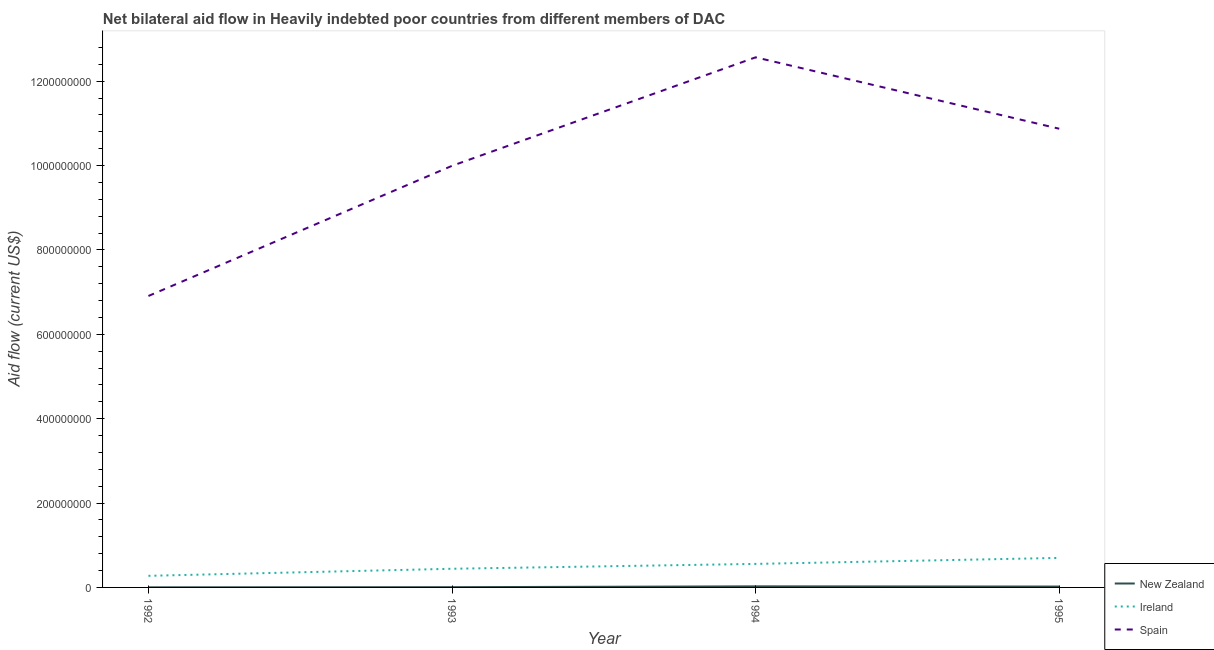Is the number of lines equal to the number of legend labels?
Ensure brevity in your answer.  Yes. What is the amount of aid provided by new zealand in 1992?
Ensure brevity in your answer.  2.30e+05. Across all years, what is the maximum amount of aid provided by spain?
Provide a succinct answer. 1.26e+09. Across all years, what is the minimum amount of aid provided by ireland?
Offer a very short reply. 2.75e+07. In which year was the amount of aid provided by ireland maximum?
Your response must be concise. 1995. In which year was the amount of aid provided by spain minimum?
Offer a very short reply. 1992. What is the total amount of aid provided by ireland in the graph?
Keep it short and to the point. 1.97e+08. What is the difference between the amount of aid provided by ireland in 1992 and that in 1995?
Make the answer very short. -4.25e+07. What is the difference between the amount of aid provided by new zealand in 1995 and the amount of aid provided by ireland in 1993?
Provide a succinct answer. -4.22e+07. What is the average amount of aid provided by spain per year?
Your response must be concise. 1.01e+09. In the year 1995, what is the difference between the amount of aid provided by new zealand and amount of aid provided by ireland?
Make the answer very short. -6.79e+07. What is the ratio of the amount of aid provided by ireland in 1992 to that in 1995?
Your answer should be very brief. 0.39. What is the difference between the highest and the second highest amount of aid provided by ireland?
Your answer should be compact. 1.42e+07. What is the difference between the highest and the lowest amount of aid provided by ireland?
Make the answer very short. 4.25e+07. Does the amount of aid provided by spain monotonically increase over the years?
Your answer should be very brief. No. Is the amount of aid provided by ireland strictly greater than the amount of aid provided by spain over the years?
Your answer should be very brief. No. How many lines are there?
Offer a terse response. 3. Does the graph contain grids?
Your answer should be compact. No. Where does the legend appear in the graph?
Ensure brevity in your answer.  Bottom right. How many legend labels are there?
Offer a terse response. 3. What is the title of the graph?
Provide a succinct answer. Net bilateral aid flow in Heavily indebted poor countries from different members of DAC. Does "Refusal of sex" appear as one of the legend labels in the graph?
Provide a succinct answer. No. What is the label or title of the Y-axis?
Make the answer very short. Aid flow (current US$). What is the Aid flow (current US$) of New Zealand in 1992?
Keep it short and to the point. 2.30e+05. What is the Aid flow (current US$) of Ireland in 1992?
Your answer should be very brief. 2.75e+07. What is the Aid flow (current US$) in Spain in 1992?
Offer a terse response. 6.91e+08. What is the Aid flow (current US$) of New Zealand in 1993?
Make the answer very short. 6.00e+05. What is the Aid flow (current US$) of Ireland in 1993?
Make the answer very short. 4.42e+07. What is the Aid flow (current US$) of Spain in 1993?
Make the answer very short. 9.99e+08. What is the Aid flow (current US$) of New Zealand in 1994?
Your answer should be very brief. 2.55e+06. What is the Aid flow (current US$) of Ireland in 1994?
Provide a short and direct response. 5.58e+07. What is the Aid flow (current US$) in Spain in 1994?
Your answer should be compact. 1.26e+09. What is the Aid flow (current US$) of New Zealand in 1995?
Provide a short and direct response. 2.08e+06. What is the Aid flow (current US$) of Ireland in 1995?
Offer a terse response. 7.00e+07. What is the Aid flow (current US$) of Spain in 1995?
Your answer should be very brief. 1.09e+09. Across all years, what is the maximum Aid flow (current US$) of New Zealand?
Make the answer very short. 2.55e+06. Across all years, what is the maximum Aid flow (current US$) of Ireland?
Offer a terse response. 7.00e+07. Across all years, what is the maximum Aid flow (current US$) of Spain?
Ensure brevity in your answer.  1.26e+09. Across all years, what is the minimum Aid flow (current US$) of New Zealand?
Offer a very short reply. 2.30e+05. Across all years, what is the minimum Aid flow (current US$) of Ireland?
Your response must be concise. 2.75e+07. Across all years, what is the minimum Aid flow (current US$) of Spain?
Your answer should be compact. 6.91e+08. What is the total Aid flow (current US$) in New Zealand in the graph?
Offer a terse response. 5.46e+06. What is the total Aid flow (current US$) in Ireland in the graph?
Provide a succinct answer. 1.97e+08. What is the total Aid flow (current US$) in Spain in the graph?
Your response must be concise. 4.03e+09. What is the difference between the Aid flow (current US$) in New Zealand in 1992 and that in 1993?
Give a very brief answer. -3.70e+05. What is the difference between the Aid flow (current US$) in Ireland in 1992 and that in 1993?
Give a very brief answer. -1.68e+07. What is the difference between the Aid flow (current US$) of Spain in 1992 and that in 1993?
Your response must be concise. -3.09e+08. What is the difference between the Aid flow (current US$) in New Zealand in 1992 and that in 1994?
Make the answer very short. -2.32e+06. What is the difference between the Aid flow (current US$) in Ireland in 1992 and that in 1994?
Provide a succinct answer. -2.83e+07. What is the difference between the Aid flow (current US$) in Spain in 1992 and that in 1994?
Provide a succinct answer. -5.66e+08. What is the difference between the Aid flow (current US$) of New Zealand in 1992 and that in 1995?
Give a very brief answer. -1.85e+06. What is the difference between the Aid flow (current US$) of Ireland in 1992 and that in 1995?
Provide a succinct answer. -4.25e+07. What is the difference between the Aid flow (current US$) of Spain in 1992 and that in 1995?
Your answer should be compact. -3.96e+08. What is the difference between the Aid flow (current US$) of New Zealand in 1993 and that in 1994?
Provide a short and direct response. -1.95e+06. What is the difference between the Aid flow (current US$) of Ireland in 1993 and that in 1994?
Your answer should be very brief. -1.15e+07. What is the difference between the Aid flow (current US$) in Spain in 1993 and that in 1994?
Ensure brevity in your answer.  -2.57e+08. What is the difference between the Aid flow (current US$) of New Zealand in 1993 and that in 1995?
Keep it short and to the point. -1.48e+06. What is the difference between the Aid flow (current US$) of Ireland in 1993 and that in 1995?
Provide a short and direct response. -2.57e+07. What is the difference between the Aid flow (current US$) of Spain in 1993 and that in 1995?
Your answer should be very brief. -8.79e+07. What is the difference between the Aid flow (current US$) in New Zealand in 1994 and that in 1995?
Your answer should be compact. 4.70e+05. What is the difference between the Aid flow (current US$) in Ireland in 1994 and that in 1995?
Give a very brief answer. -1.42e+07. What is the difference between the Aid flow (current US$) in Spain in 1994 and that in 1995?
Provide a short and direct response. 1.69e+08. What is the difference between the Aid flow (current US$) in New Zealand in 1992 and the Aid flow (current US$) in Ireland in 1993?
Provide a short and direct response. -4.40e+07. What is the difference between the Aid flow (current US$) in New Zealand in 1992 and the Aid flow (current US$) in Spain in 1993?
Provide a succinct answer. -9.99e+08. What is the difference between the Aid flow (current US$) of Ireland in 1992 and the Aid flow (current US$) of Spain in 1993?
Keep it short and to the point. -9.72e+08. What is the difference between the Aid flow (current US$) of New Zealand in 1992 and the Aid flow (current US$) of Ireland in 1994?
Your answer should be compact. -5.55e+07. What is the difference between the Aid flow (current US$) of New Zealand in 1992 and the Aid flow (current US$) of Spain in 1994?
Make the answer very short. -1.26e+09. What is the difference between the Aid flow (current US$) of Ireland in 1992 and the Aid flow (current US$) of Spain in 1994?
Your answer should be compact. -1.23e+09. What is the difference between the Aid flow (current US$) of New Zealand in 1992 and the Aid flow (current US$) of Ireland in 1995?
Offer a terse response. -6.98e+07. What is the difference between the Aid flow (current US$) in New Zealand in 1992 and the Aid flow (current US$) in Spain in 1995?
Give a very brief answer. -1.09e+09. What is the difference between the Aid flow (current US$) in Ireland in 1992 and the Aid flow (current US$) in Spain in 1995?
Provide a short and direct response. -1.06e+09. What is the difference between the Aid flow (current US$) in New Zealand in 1993 and the Aid flow (current US$) in Ireland in 1994?
Your answer should be very brief. -5.52e+07. What is the difference between the Aid flow (current US$) in New Zealand in 1993 and the Aid flow (current US$) in Spain in 1994?
Your answer should be compact. -1.26e+09. What is the difference between the Aid flow (current US$) of Ireland in 1993 and the Aid flow (current US$) of Spain in 1994?
Offer a terse response. -1.21e+09. What is the difference between the Aid flow (current US$) in New Zealand in 1993 and the Aid flow (current US$) in Ireland in 1995?
Offer a very short reply. -6.94e+07. What is the difference between the Aid flow (current US$) in New Zealand in 1993 and the Aid flow (current US$) in Spain in 1995?
Make the answer very short. -1.09e+09. What is the difference between the Aid flow (current US$) in Ireland in 1993 and the Aid flow (current US$) in Spain in 1995?
Offer a very short reply. -1.04e+09. What is the difference between the Aid flow (current US$) in New Zealand in 1994 and the Aid flow (current US$) in Ireland in 1995?
Provide a short and direct response. -6.74e+07. What is the difference between the Aid flow (current US$) of New Zealand in 1994 and the Aid flow (current US$) of Spain in 1995?
Give a very brief answer. -1.08e+09. What is the difference between the Aid flow (current US$) of Ireland in 1994 and the Aid flow (current US$) of Spain in 1995?
Your answer should be compact. -1.03e+09. What is the average Aid flow (current US$) in New Zealand per year?
Keep it short and to the point. 1.36e+06. What is the average Aid flow (current US$) in Ireland per year?
Provide a short and direct response. 4.94e+07. What is the average Aid flow (current US$) of Spain per year?
Provide a short and direct response. 1.01e+09. In the year 1992, what is the difference between the Aid flow (current US$) in New Zealand and Aid flow (current US$) in Ireland?
Offer a very short reply. -2.73e+07. In the year 1992, what is the difference between the Aid flow (current US$) of New Zealand and Aid flow (current US$) of Spain?
Your response must be concise. -6.91e+08. In the year 1992, what is the difference between the Aid flow (current US$) in Ireland and Aid flow (current US$) in Spain?
Provide a short and direct response. -6.63e+08. In the year 1993, what is the difference between the Aid flow (current US$) of New Zealand and Aid flow (current US$) of Ireland?
Your answer should be compact. -4.36e+07. In the year 1993, what is the difference between the Aid flow (current US$) of New Zealand and Aid flow (current US$) of Spain?
Your answer should be compact. -9.99e+08. In the year 1993, what is the difference between the Aid flow (current US$) of Ireland and Aid flow (current US$) of Spain?
Offer a terse response. -9.55e+08. In the year 1994, what is the difference between the Aid flow (current US$) of New Zealand and Aid flow (current US$) of Ireland?
Provide a succinct answer. -5.32e+07. In the year 1994, what is the difference between the Aid flow (current US$) of New Zealand and Aid flow (current US$) of Spain?
Your answer should be very brief. -1.25e+09. In the year 1994, what is the difference between the Aid flow (current US$) of Ireland and Aid flow (current US$) of Spain?
Provide a short and direct response. -1.20e+09. In the year 1995, what is the difference between the Aid flow (current US$) in New Zealand and Aid flow (current US$) in Ireland?
Your answer should be compact. -6.79e+07. In the year 1995, what is the difference between the Aid flow (current US$) in New Zealand and Aid flow (current US$) in Spain?
Keep it short and to the point. -1.09e+09. In the year 1995, what is the difference between the Aid flow (current US$) in Ireland and Aid flow (current US$) in Spain?
Provide a short and direct response. -1.02e+09. What is the ratio of the Aid flow (current US$) in New Zealand in 1992 to that in 1993?
Your answer should be compact. 0.38. What is the ratio of the Aid flow (current US$) of Ireland in 1992 to that in 1993?
Provide a succinct answer. 0.62. What is the ratio of the Aid flow (current US$) in Spain in 1992 to that in 1993?
Keep it short and to the point. 0.69. What is the ratio of the Aid flow (current US$) of New Zealand in 1992 to that in 1994?
Provide a short and direct response. 0.09. What is the ratio of the Aid flow (current US$) in Ireland in 1992 to that in 1994?
Your answer should be compact. 0.49. What is the ratio of the Aid flow (current US$) in Spain in 1992 to that in 1994?
Your answer should be very brief. 0.55. What is the ratio of the Aid flow (current US$) of New Zealand in 1992 to that in 1995?
Offer a very short reply. 0.11. What is the ratio of the Aid flow (current US$) in Ireland in 1992 to that in 1995?
Provide a short and direct response. 0.39. What is the ratio of the Aid flow (current US$) of Spain in 1992 to that in 1995?
Your answer should be compact. 0.64. What is the ratio of the Aid flow (current US$) of New Zealand in 1993 to that in 1994?
Keep it short and to the point. 0.24. What is the ratio of the Aid flow (current US$) in Ireland in 1993 to that in 1994?
Ensure brevity in your answer.  0.79. What is the ratio of the Aid flow (current US$) of Spain in 1993 to that in 1994?
Ensure brevity in your answer.  0.8. What is the ratio of the Aid flow (current US$) in New Zealand in 1993 to that in 1995?
Provide a succinct answer. 0.29. What is the ratio of the Aid flow (current US$) in Ireland in 1993 to that in 1995?
Your response must be concise. 0.63. What is the ratio of the Aid flow (current US$) of Spain in 1993 to that in 1995?
Give a very brief answer. 0.92. What is the ratio of the Aid flow (current US$) of New Zealand in 1994 to that in 1995?
Provide a short and direct response. 1.23. What is the ratio of the Aid flow (current US$) in Ireland in 1994 to that in 1995?
Offer a very short reply. 0.8. What is the ratio of the Aid flow (current US$) of Spain in 1994 to that in 1995?
Your response must be concise. 1.16. What is the difference between the highest and the second highest Aid flow (current US$) of New Zealand?
Keep it short and to the point. 4.70e+05. What is the difference between the highest and the second highest Aid flow (current US$) in Ireland?
Your answer should be compact. 1.42e+07. What is the difference between the highest and the second highest Aid flow (current US$) of Spain?
Ensure brevity in your answer.  1.69e+08. What is the difference between the highest and the lowest Aid flow (current US$) of New Zealand?
Ensure brevity in your answer.  2.32e+06. What is the difference between the highest and the lowest Aid flow (current US$) of Ireland?
Your answer should be very brief. 4.25e+07. What is the difference between the highest and the lowest Aid flow (current US$) in Spain?
Your answer should be compact. 5.66e+08. 